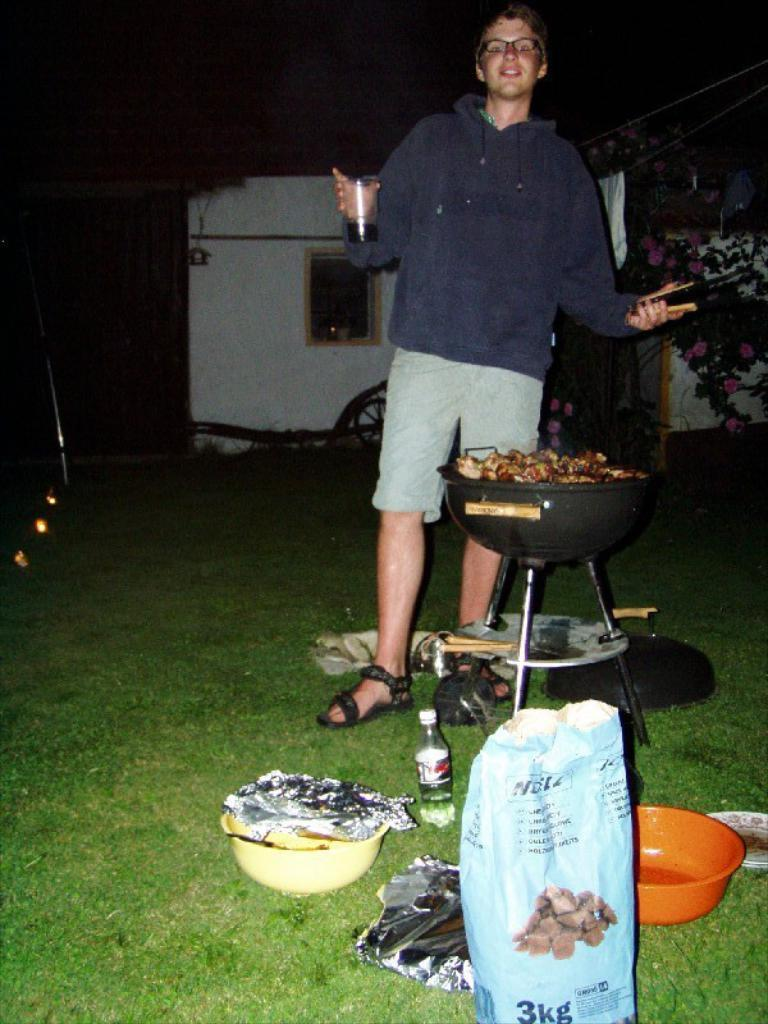Provide a one-sentence caption for the provided image. A man is standing at a grill with a 3kg bag near him. 